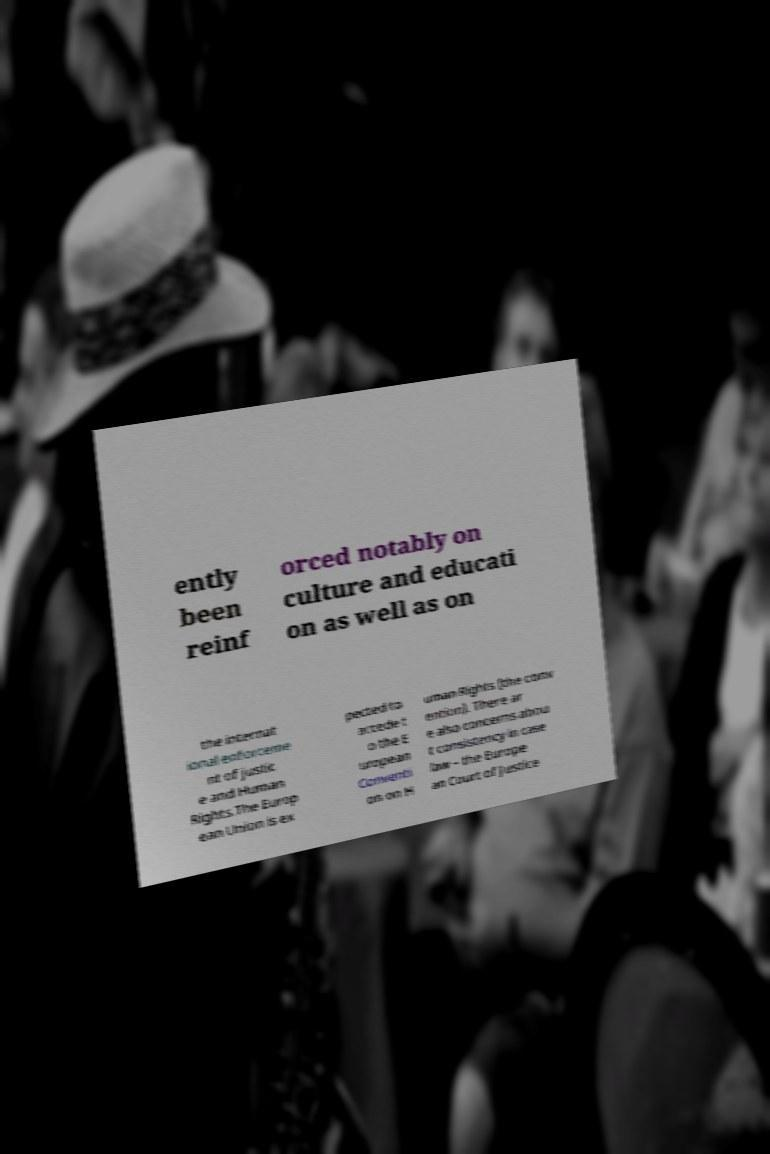Can you accurately transcribe the text from the provided image for me? ently been reinf orced notably on culture and educati on as well as on the internat ional enforceme nt of justic e and Human Rights.The Europ ean Union is ex pected to accede t o the E uropean Conventi on on H uman Rights (the conv ention). There ar e also concerns abou t consistency in case law – the Europe an Court of Justice 